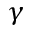Convert formula to latex. <formula><loc_0><loc_0><loc_500><loc_500>\gamma</formula> 